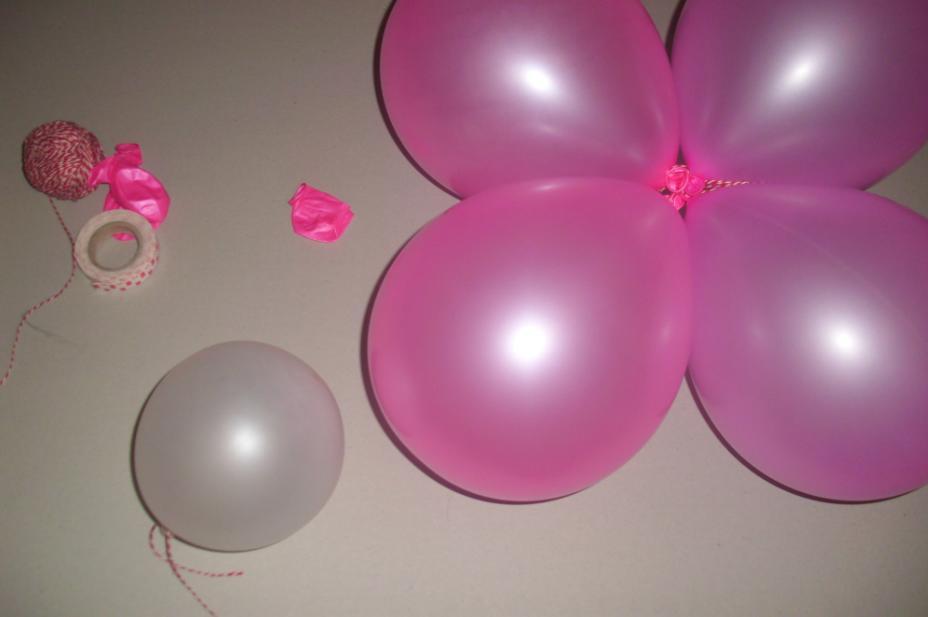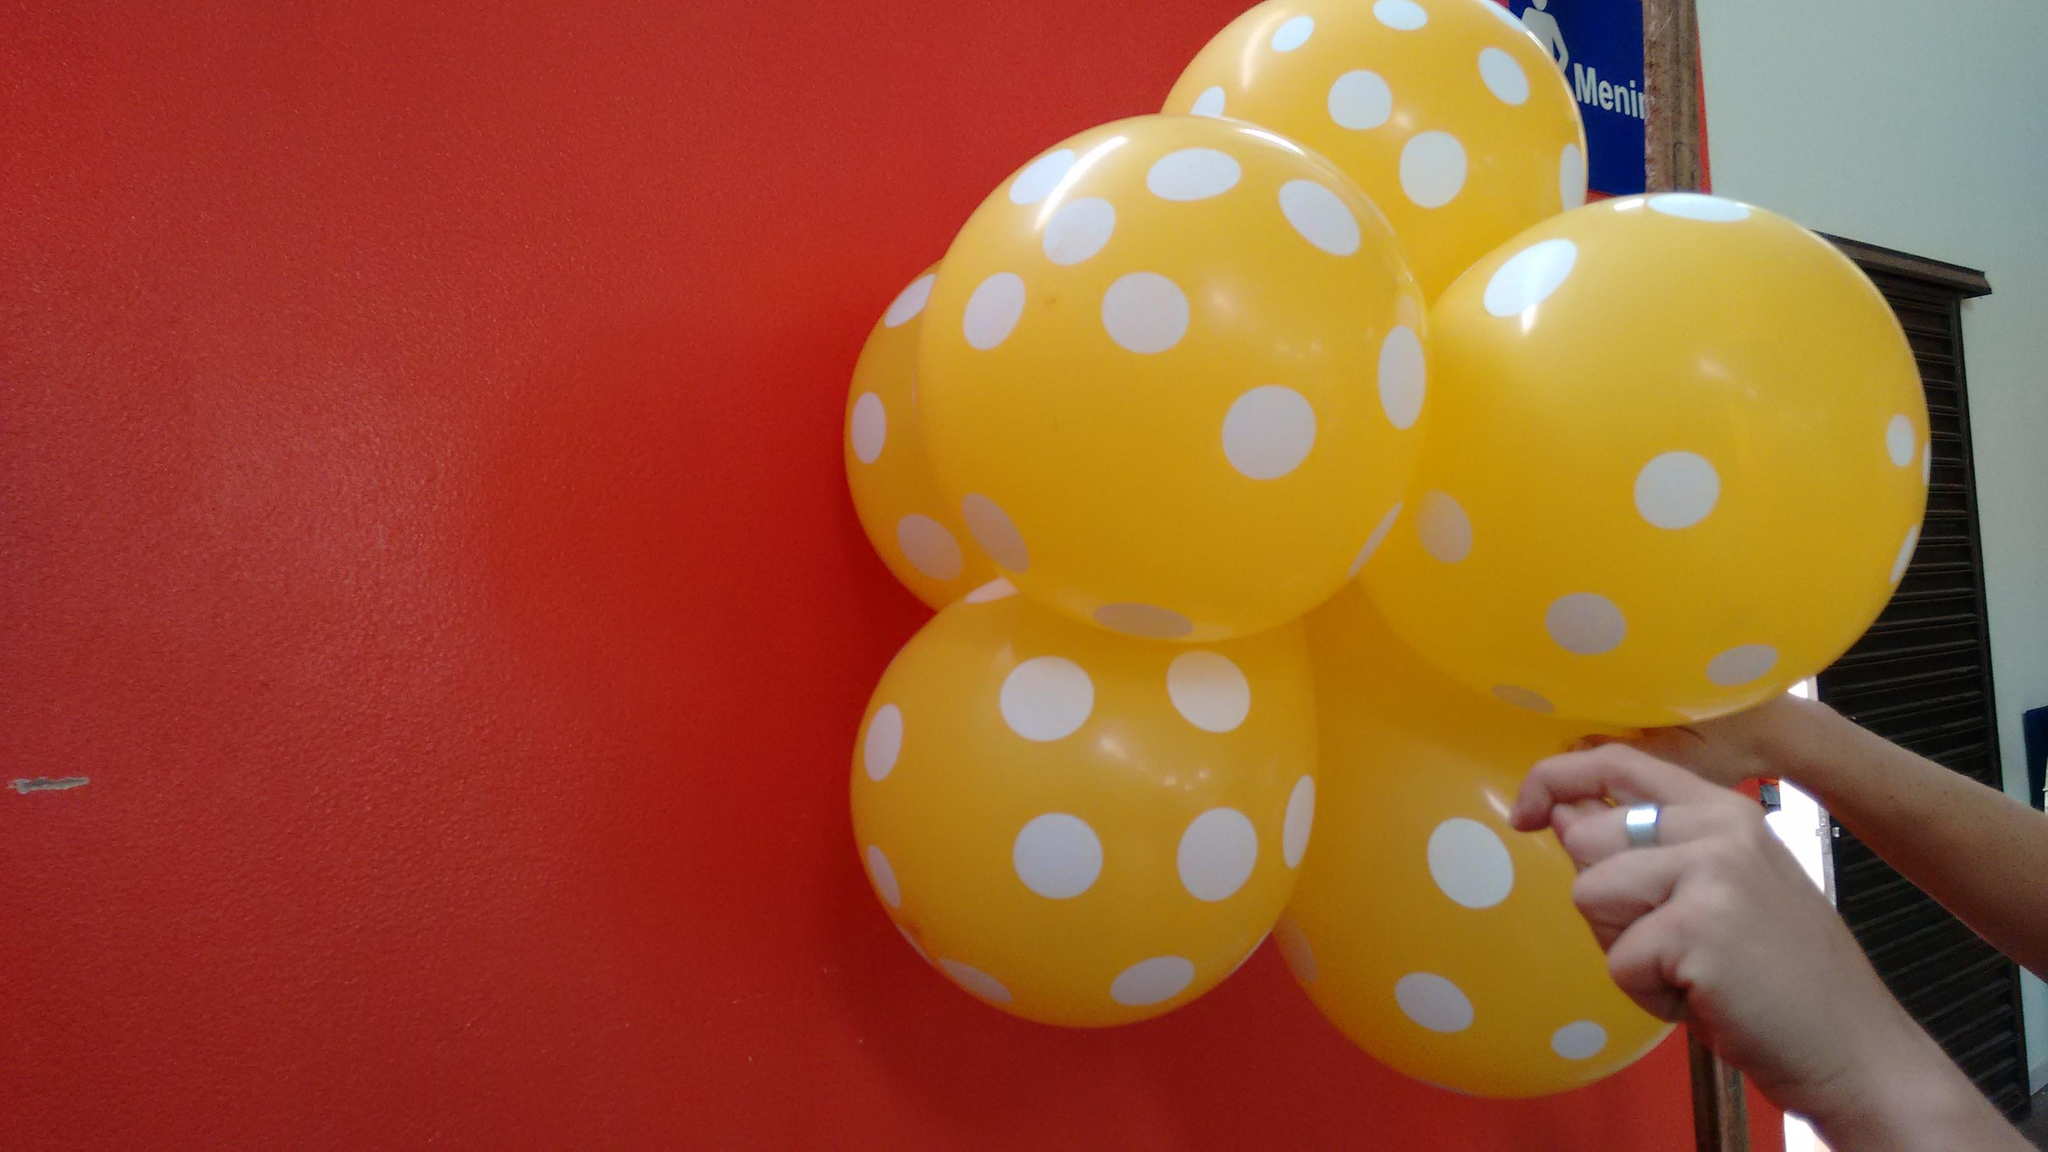The first image is the image on the left, the second image is the image on the right. Considering the images on both sides, is "The left image shows at least four balloons of the same color joined together, and one balloon of a different color." valid? Answer yes or no. Yes. The first image is the image on the left, the second image is the image on the right. Assess this claim about the two images: "In at least one image there is a total of five full balloons.". Correct or not? Answer yes or no. Yes. 